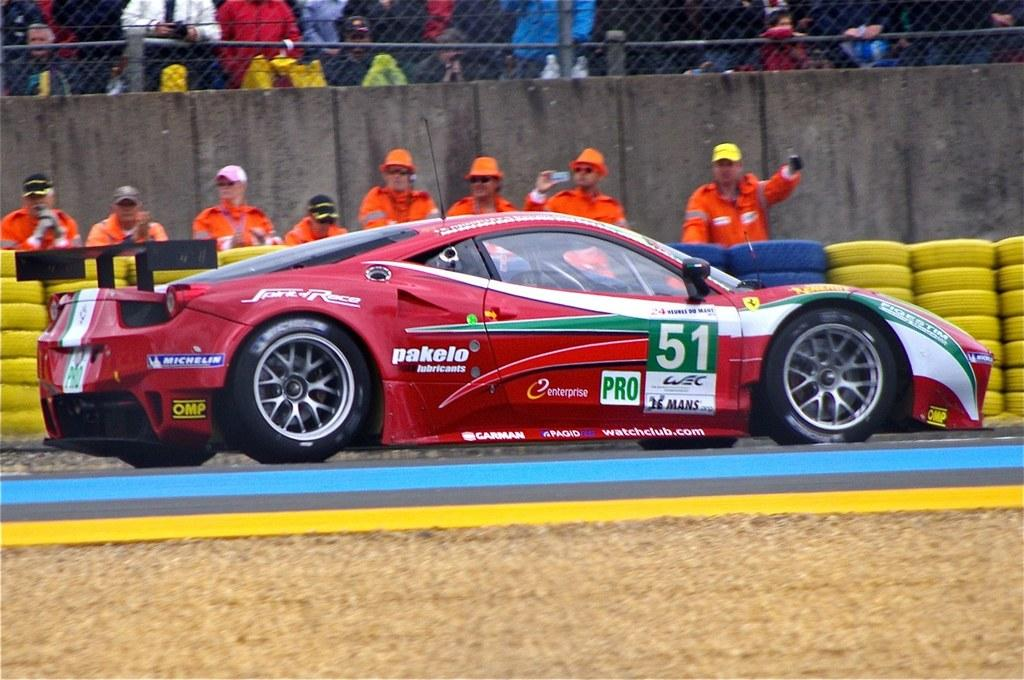What type of vehicle is in the foreground of the image? There is a sports car in the foreground of the image. Where is the sports car located? The sports car is on the road. What can be seen in the background of the image? In the background of the image, there are yellow colored tyres, a stand, persons, a wall, fencing, and a crowd. What language is being spoken by the paper in the image? There is no paper present in the image, and therefore no language can be associated with it. 